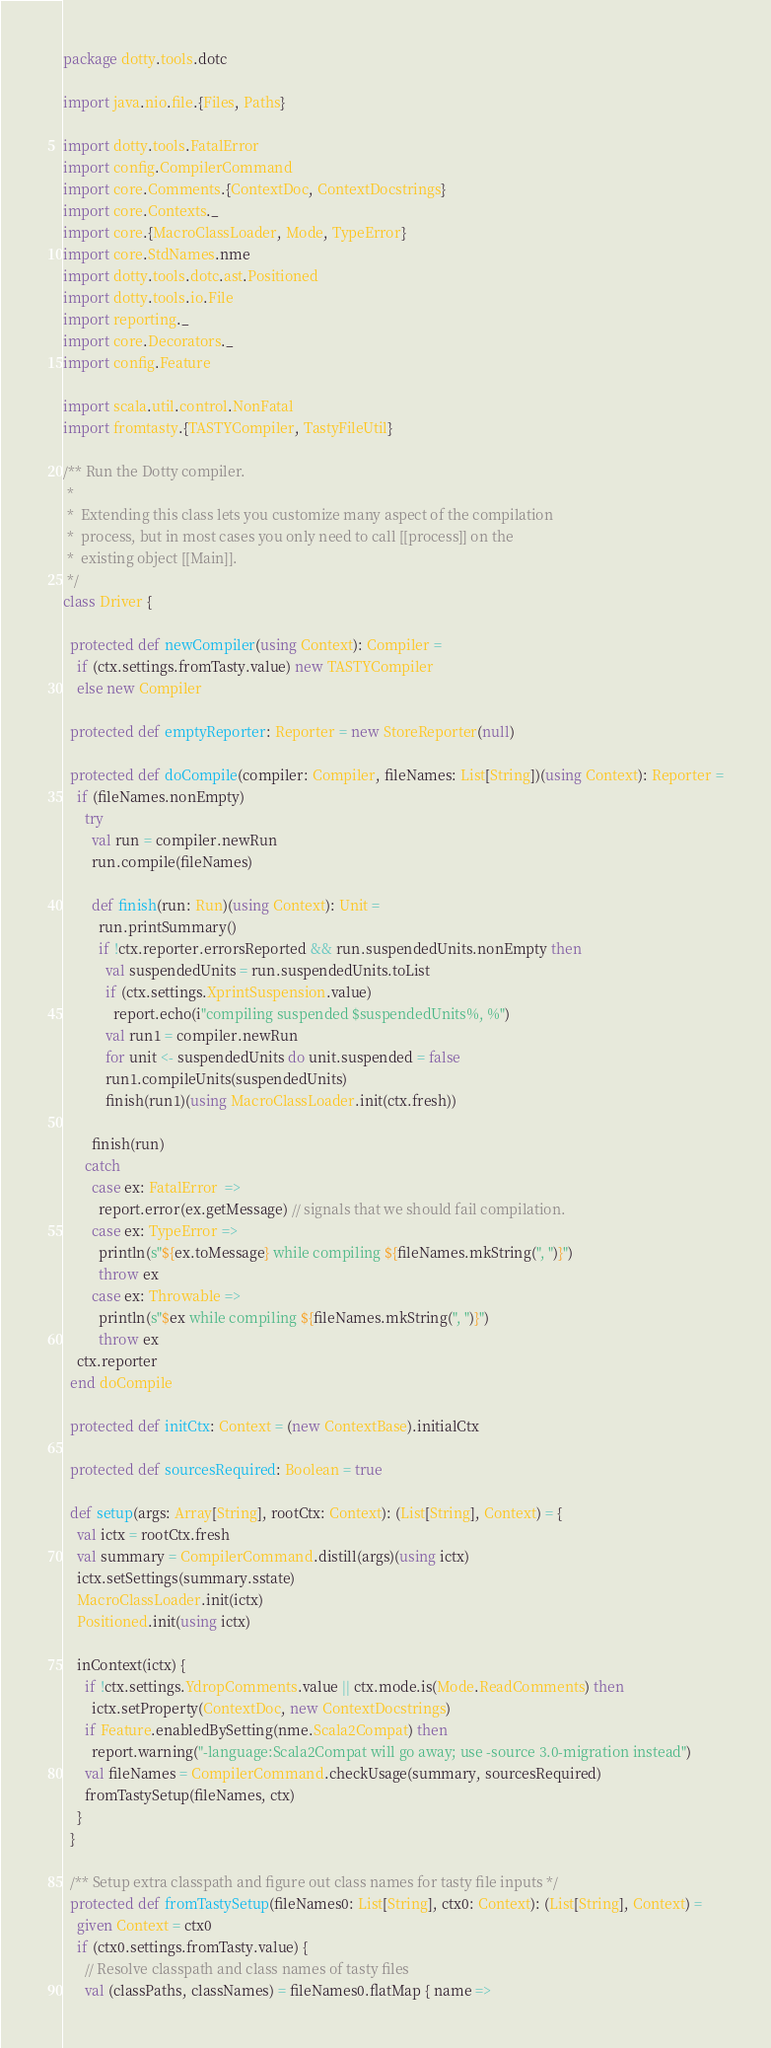<code> <loc_0><loc_0><loc_500><loc_500><_Scala_>package dotty.tools.dotc

import java.nio.file.{Files, Paths}

import dotty.tools.FatalError
import config.CompilerCommand
import core.Comments.{ContextDoc, ContextDocstrings}
import core.Contexts._
import core.{MacroClassLoader, Mode, TypeError}
import core.StdNames.nme
import dotty.tools.dotc.ast.Positioned
import dotty.tools.io.File
import reporting._
import core.Decorators._
import config.Feature

import scala.util.control.NonFatal
import fromtasty.{TASTYCompiler, TastyFileUtil}

/** Run the Dotty compiler.
 *
 *  Extending this class lets you customize many aspect of the compilation
 *  process, but in most cases you only need to call [[process]] on the
 *  existing object [[Main]].
 */
class Driver {

  protected def newCompiler(using Context): Compiler =
    if (ctx.settings.fromTasty.value) new TASTYCompiler
    else new Compiler

  protected def emptyReporter: Reporter = new StoreReporter(null)

  protected def doCompile(compiler: Compiler, fileNames: List[String])(using Context): Reporter =
    if (fileNames.nonEmpty)
      try
        val run = compiler.newRun
        run.compile(fileNames)

        def finish(run: Run)(using Context): Unit =
          run.printSummary()
          if !ctx.reporter.errorsReported && run.suspendedUnits.nonEmpty then
            val suspendedUnits = run.suspendedUnits.toList
            if (ctx.settings.XprintSuspension.value)
              report.echo(i"compiling suspended $suspendedUnits%, %")
            val run1 = compiler.newRun
            for unit <- suspendedUnits do unit.suspended = false
            run1.compileUnits(suspendedUnits)
            finish(run1)(using MacroClassLoader.init(ctx.fresh))

        finish(run)
      catch
        case ex: FatalError  =>
          report.error(ex.getMessage) // signals that we should fail compilation.
        case ex: TypeError =>
          println(s"${ex.toMessage} while compiling ${fileNames.mkString(", ")}")
          throw ex
        case ex: Throwable =>
          println(s"$ex while compiling ${fileNames.mkString(", ")}")
          throw ex
    ctx.reporter
  end doCompile

  protected def initCtx: Context = (new ContextBase).initialCtx

  protected def sourcesRequired: Boolean = true

  def setup(args: Array[String], rootCtx: Context): (List[String], Context) = {
    val ictx = rootCtx.fresh
    val summary = CompilerCommand.distill(args)(using ictx)
    ictx.setSettings(summary.sstate)
    MacroClassLoader.init(ictx)
    Positioned.init(using ictx)

    inContext(ictx) {
      if !ctx.settings.YdropComments.value || ctx.mode.is(Mode.ReadComments) then
        ictx.setProperty(ContextDoc, new ContextDocstrings)
      if Feature.enabledBySetting(nme.Scala2Compat) then
        report.warning("-language:Scala2Compat will go away; use -source 3.0-migration instead")
      val fileNames = CompilerCommand.checkUsage(summary, sourcesRequired)
      fromTastySetup(fileNames, ctx)
    }
  }

  /** Setup extra classpath and figure out class names for tasty file inputs */
  protected def fromTastySetup(fileNames0: List[String], ctx0: Context): (List[String], Context) =
    given Context = ctx0
    if (ctx0.settings.fromTasty.value) {
      // Resolve classpath and class names of tasty files
      val (classPaths, classNames) = fileNames0.flatMap { name =></code> 